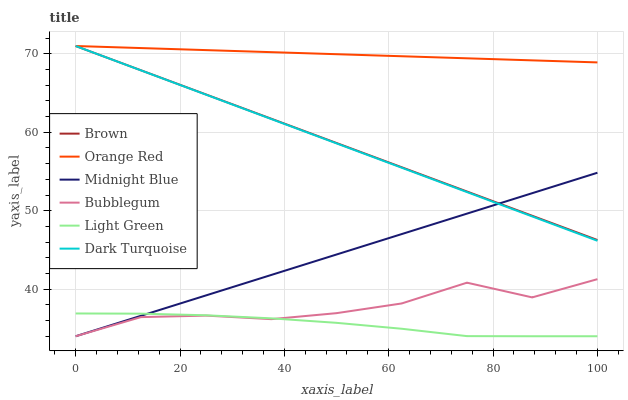Does Light Green have the minimum area under the curve?
Answer yes or no. Yes. Does Orange Red have the maximum area under the curve?
Answer yes or no. Yes. Does Midnight Blue have the minimum area under the curve?
Answer yes or no. No. Does Midnight Blue have the maximum area under the curve?
Answer yes or no. No. Is Dark Turquoise the smoothest?
Answer yes or no. Yes. Is Bubblegum the roughest?
Answer yes or no. Yes. Is Midnight Blue the smoothest?
Answer yes or no. No. Is Midnight Blue the roughest?
Answer yes or no. No. Does Midnight Blue have the lowest value?
Answer yes or no. Yes. Does Dark Turquoise have the lowest value?
Answer yes or no. No. Does Orange Red have the highest value?
Answer yes or no. Yes. Does Midnight Blue have the highest value?
Answer yes or no. No. Is Light Green less than Brown?
Answer yes or no. Yes. Is Brown greater than Bubblegum?
Answer yes or no. Yes. Does Midnight Blue intersect Bubblegum?
Answer yes or no. Yes. Is Midnight Blue less than Bubblegum?
Answer yes or no. No. Is Midnight Blue greater than Bubblegum?
Answer yes or no. No. Does Light Green intersect Brown?
Answer yes or no. No. 